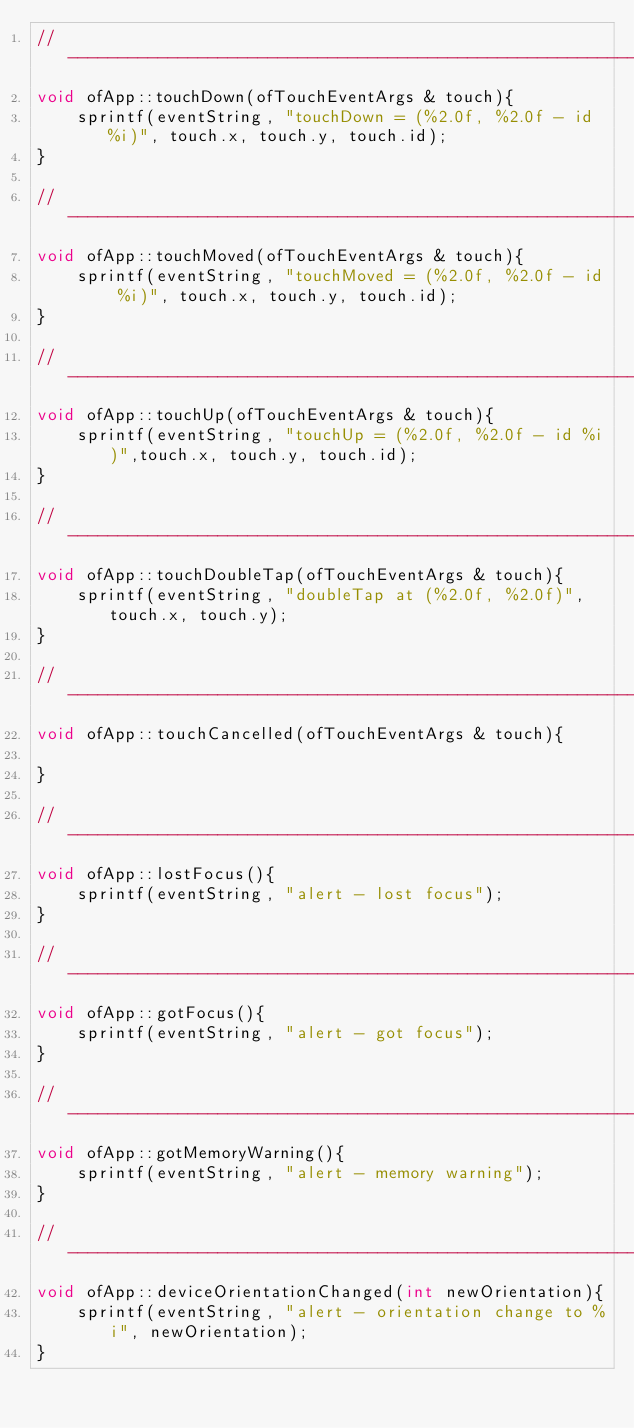<code> <loc_0><loc_0><loc_500><loc_500><_ObjectiveC_>//--------------------------------------------------------------
void ofApp::touchDown(ofTouchEventArgs & touch){
	sprintf(eventString, "touchDown = (%2.0f, %2.0f - id %i)", touch.x, touch.y, touch.id);
}

//--------------------------------------------------------------
void ofApp::touchMoved(ofTouchEventArgs & touch){
	sprintf(eventString, "touchMoved = (%2.0f, %2.0f - id %i)", touch.x, touch.y, touch.id);
}

//--------------------------------------------------------------
void ofApp::touchUp(ofTouchEventArgs & touch){
	sprintf(eventString, "touchUp = (%2.0f, %2.0f - id %i)",touch.x, touch.y, touch.id);
}

//--------------------------------------------------------------
void ofApp::touchDoubleTap(ofTouchEventArgs & touch){
	sprintf(eventString, "doubleTap at (%2.0f, %2.0f)",touch.x, touch.y);
}

//--------------------------------------------------------------
void ofApp::touchCancelled(ofTouchEventArgs & touch){
    
}

//--------------------------------------------------------------
void ofApp::lostFocus(){
	sprintf(eventString, "alert - lost focus");
}

//--------------------------------------------------------------
void ofApp::gotFocus(){
	sprintf(eventString, "alert - got focus");
}

//--------------------------------------------------------------
void ofApp::gotMemoryWarning(){
	sprintf(eventString, "alert - memory warning");
}

//--------------------------------------------------------------
void ofApp::deviceOrientationChanged(int newOrientation){
	sprintf(eventString, "alert - orientation change to %i", newOrientation);
}

</code> 